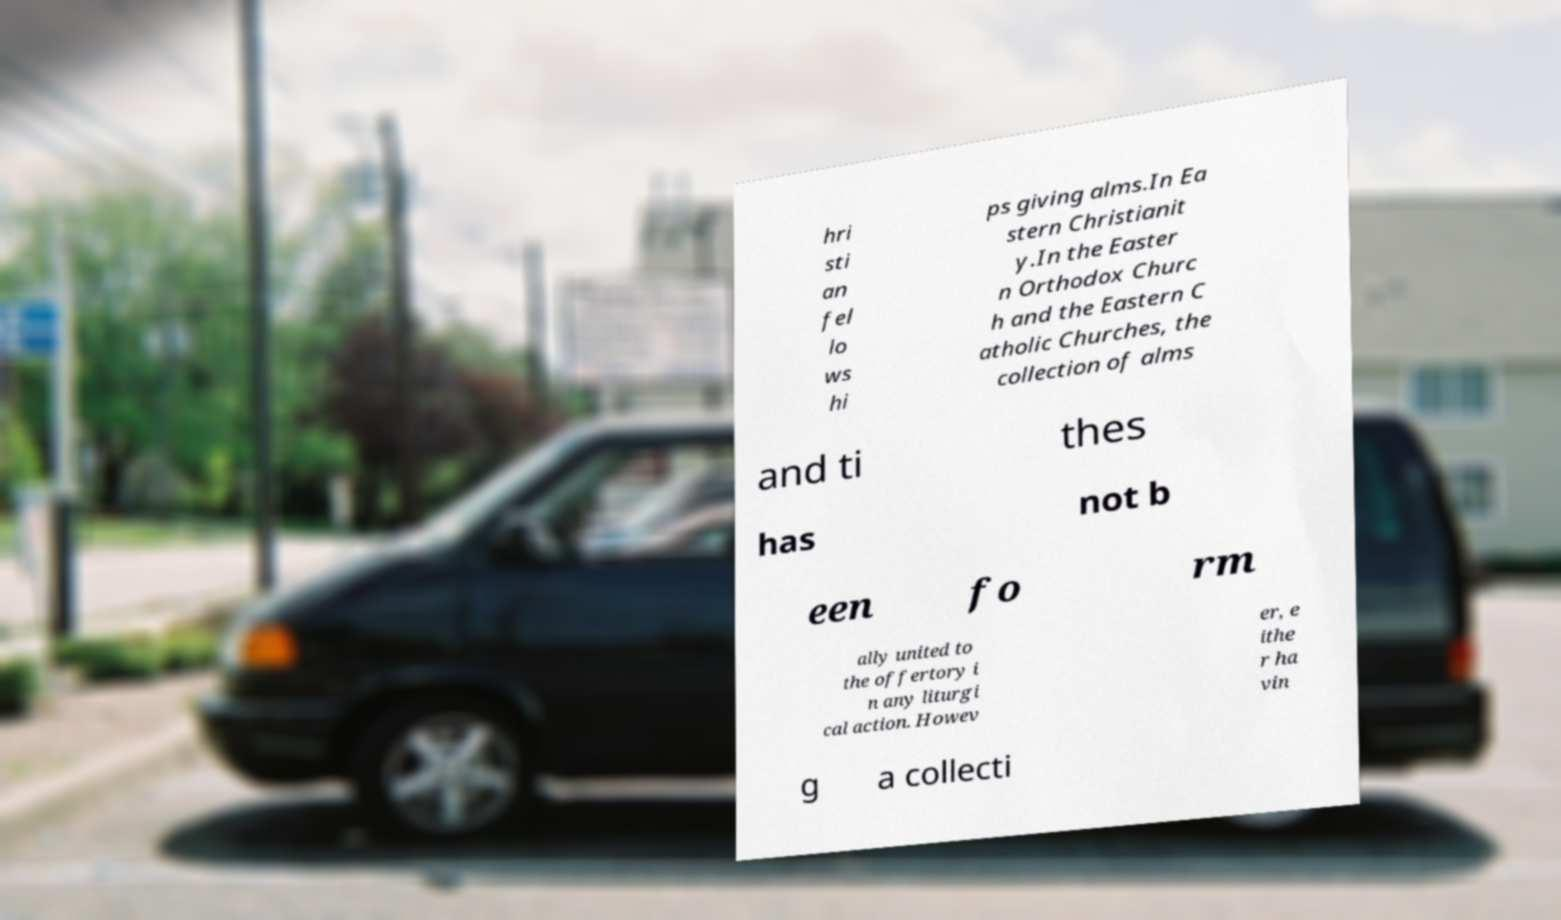Please identify and transcribe the text found in this image. hri sti an fel lo ws hi ps giving alms.In Ea stern Christianit y.In the Easter n Orthodox Churc h and the Eastern C atholic Churches, the collection of alms and ti thes has not b een fo rm ally united to the offertory i n any liturgi cal action. Howev er, e ithe r ha vin g a collecti 